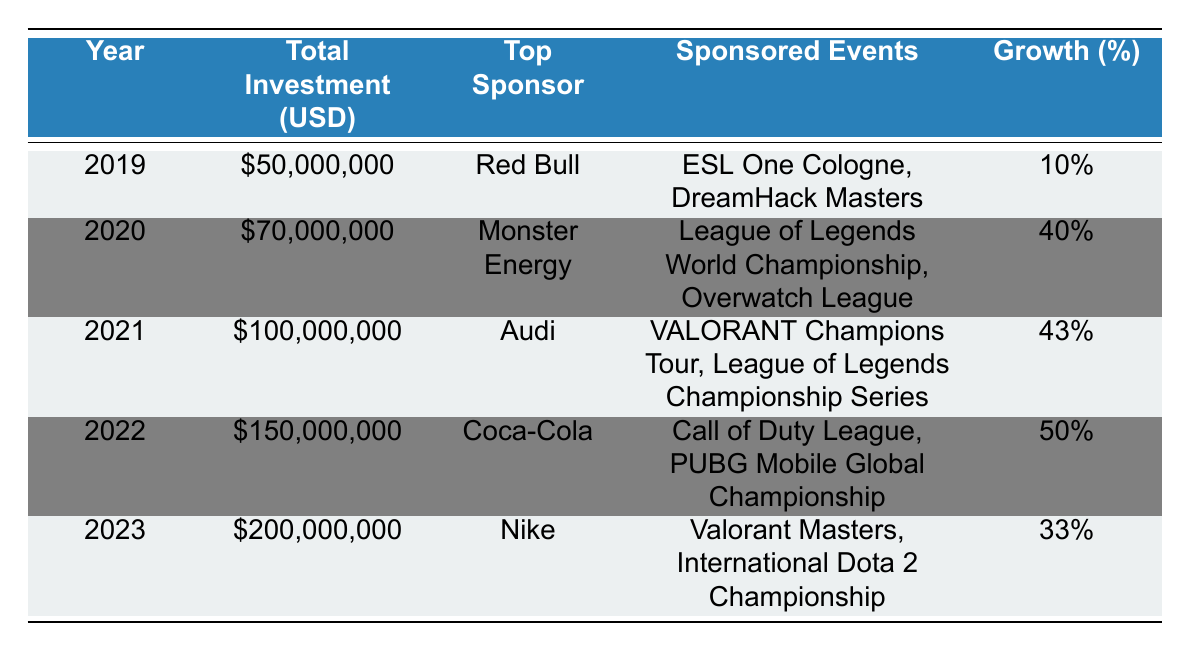What was the total sponsorship investment in esports in 2022? The table shows that the total investment in 2022 was \$150,000,000.
Answer: \$150,000,000 Who was the top sponsor in 2021? According to the table, the top sponsor in 2021 was Audi.
Answer: Audi Which year saw the highest percentage growth in sponsorship investment? By examining the growth percentages, 2022 had the highest growth at 50%.
Answer: 2022 What are the sponsored events by Coca-Cola in 2022? The table states that Coca-Cola sponsored the Call of Duty League and PUBG Mobile Global Championship in 2022.
Answer: Call of Duty League, PUBG Mobile Global Championship What was the total investment in esports for the years 2019 and 2020 combined? To find the total, add the investments for 2019 (\$50,000,000) and 2020 (\$70,000,000), which equals \$120,000,000.
Answer: \$120,000,000 Was Monster Energy the top sponsor in 2019? The table indicates that the top sponsor in 2019 was Red Bull, not Monster Energy.
Answer: No What is the difference in sponsorship investment between 2023 and 2020? The investment in 2023 is \$200,000,000 and in 2020 is \$70,000,000, so the difference is \$200,000,000 - \$70,000,000 = \$130,000,000.
Answer: \$130,000,000 If the trend continues, what would be the projected total investment for 2024, assuming an average growth of the previous years? The average growth over the last five years is calculated by summing growth percentages (10 + 40 + 43 + 50 + 33 = 176) and dividing by 5, which gives 35.2%. Adding 35.2% to the 2023 total (200,000,000) yields approximately \$270,400,000.
Answer: \$270,400,000 Which sponsor appeared in consecutive years? Audi sponsored events in 2021 and did not sponsor in 2020, so the only consecutive sponsor is Coca-Cola in 2022.
Answer: Coca-Cola 